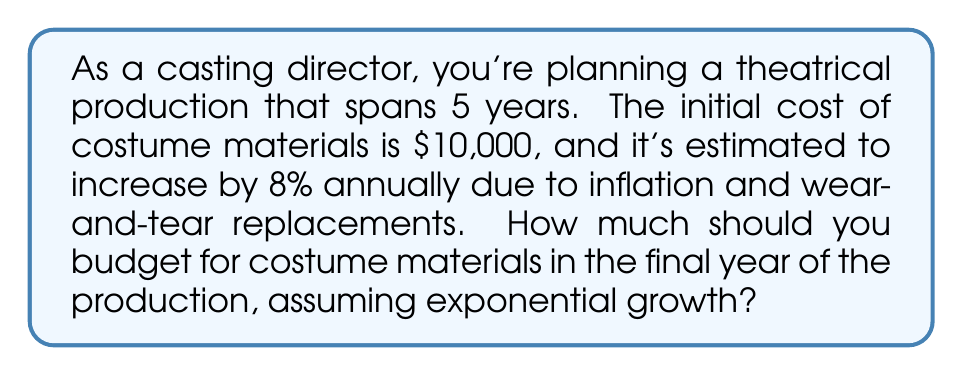Teach me how to tackle this problem. Let's approach this step-by-step:

1) We're dealing with exponential growth, which can be modeled by the function:

   $A = P(1 + r)^t$

   Where:
   $A$ = Final amount
   $P$ = Initial principal balance
   $r$ = Annual growth rate (as a decimal)
   $t$ = Number of years

2) In this case:
   $P = 10,000$
   $r = 0.08$ (8% expressed as a decimal)
   $t = 5$ (we want the cost in the final year, which is year 5)

3) Let's substitute these values into our equation:

   $A = 10,000(1 + 0.08)^5$

4) Now, let's calculate:
   
   $A = 10,000(1.08)^5$
   
   $A = 10,000(1.469328)$
   
   $A = 14,693.28$

5) Rounding to the nearest dollar:

   $A ≈ 14,693$

Therefore, you should budget $14,693 for costume materials in the final year of the production.
Answer: $14,693 